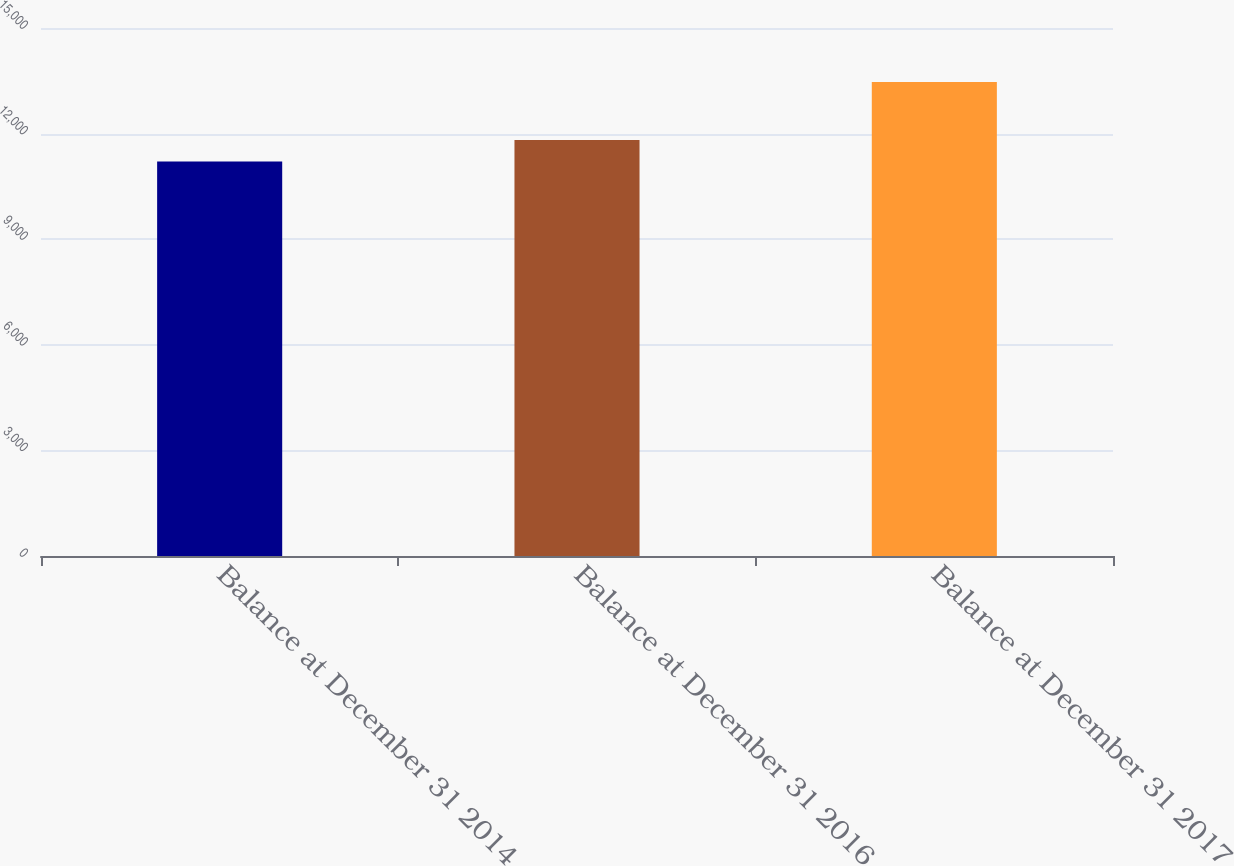Convert chart to OTSL. <chart><loc_0><loc_0><loc_500><loc_500><bar_chart><fcel>Balance at December 31 2014<fcel>Balance at December 31 2016<fcel>Balance at December 31 2017<nl><fcel>11208<fcel>11820<fcel>13468<nl></chart> 